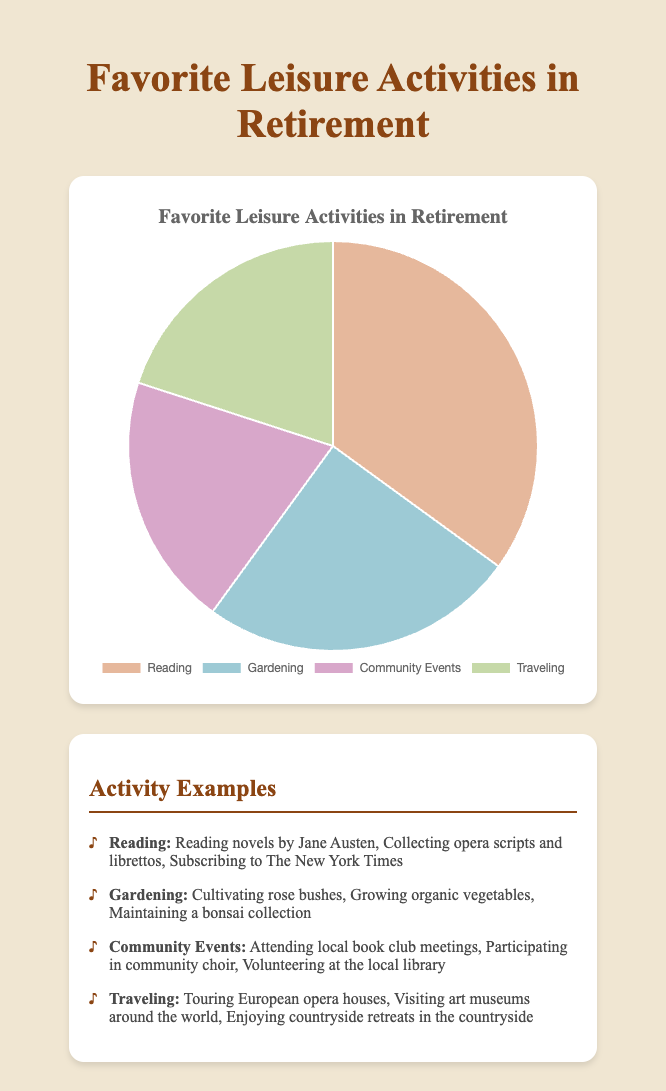What percentage of retired people enjoy Reading and Gardening together? To find the percentage of retired people who enjoy both Reading and Gardening, you add the percentages for these activities. According to the data, Reading has 35% and Gardening has 25%. Therefore, 35 + 25 = 60%
Answer: 60% Is there a larger group of retirees who prefer Gardening or Traveling? Comparing the percentages, Gardening is preferred by 25% while Traveling is preferred by 20%. Since 25% is greater than 20%, more retirees prefer Gardening.
Answer: Gardening What is the difference in percentage between those who enjoy Reading and those who enjoy Community Events? To find the difference, subtract the percentage of Community Events from the percentage of Reading. Reading has 35% and Community Events have 20%. So, 35 - 20 = 15%
Answer: 15% Which leisure activity is equally enjoyed as Traveling? According to the data, both Community Events and Traveling are enjoyed by 20% of retirees.
Answer: Community Events What is the least favored leisure activity? By examining the percentages, the least favored activities are those with the smallest percentage. Travel and Community Events both have 20%, which are the lowest among the activities listed.
Answer: Traveling and Community Events What is the total percentage of retirees participating in Community Events and Traveling? According to the pie chart, Community Events are enjoyed by 20% and Traveling by another 20%. Adding these percentages results in 20 + 20 = 40%.
Answer: 40% Which activity has the highest percentage, and what is that percentage? The activity with the highest percentage is Reading, which is enjoyed by 35% of retirees.
Answer: Reading, 35% Arrange the activities in descending order of popularity. List them with their percentages. First, order the activities by their given percentages: Reading (35%), Gardening (25%), Community Events (20%), Traveling (20%). The order from most to least popular is Reading, Gardening, Community Events, Traveling.
Answer: Reading (35%), Gardening (25%), Community Events (20%), Traveling (20%) What color represents Gardening on the pie chart? Even though the exact visual isn't provided, usually a color would be specified in the chart context. Assuming standard differentiation, Gardening could be represented by one of the colors distinct to the others, such as blue or green for nature-associated activities.
Answer: Blue or green If 1000 retirees were surveyed, how many of them would you expect to prefer Reading? With Reading being enjoyed by 35% of retirees, multiply 1000 by 0.35 to get 350.
Answer: 350 